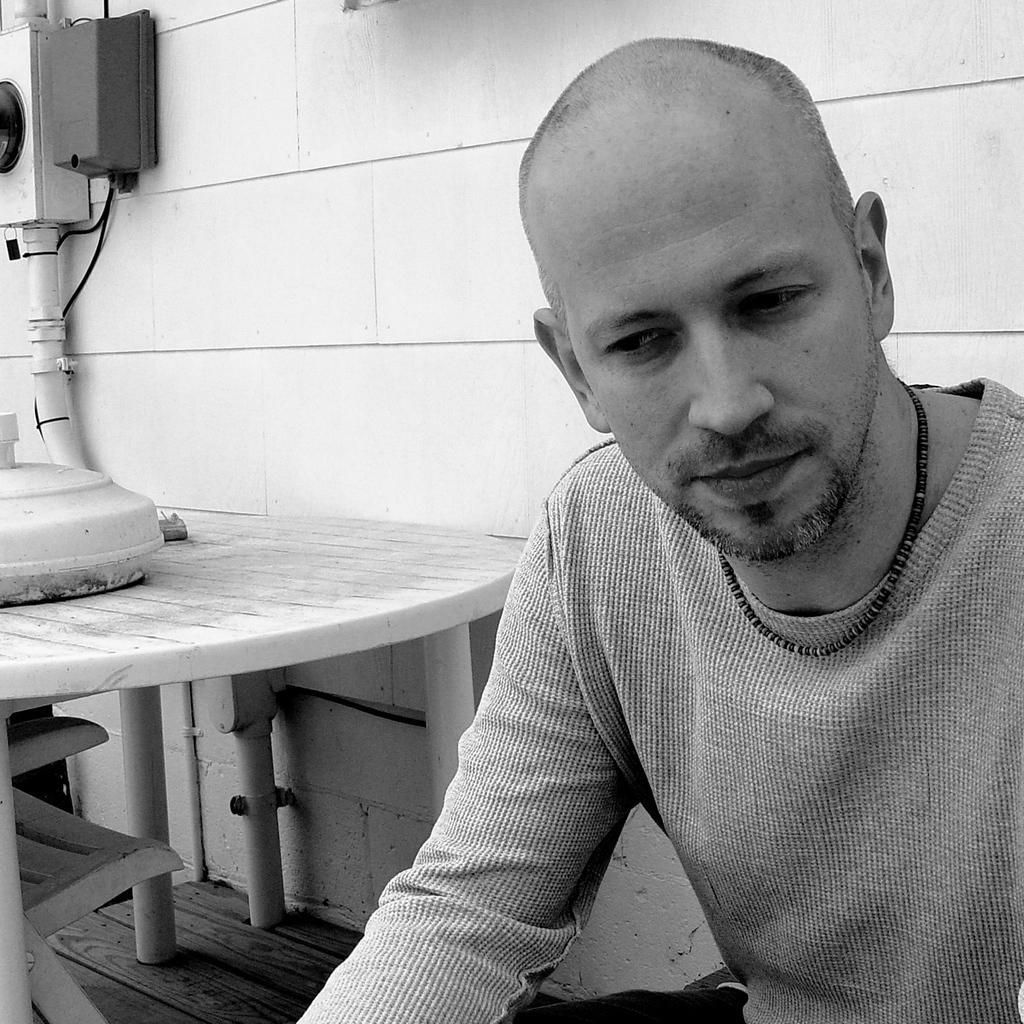Please provide a concise description of this image. In this image there is a person, and at the background there is a box on the table, chair , a box and a pipe on the wall. 